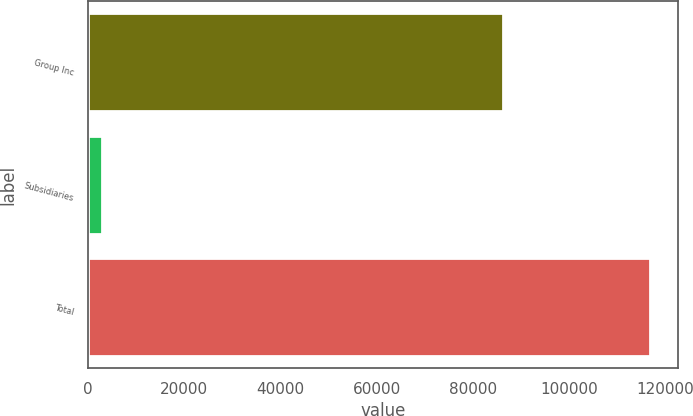Convert chart to OTSL. <chart><loc_0><loc_0><loc_500><loc_500><bar_chart><fcel>Group Inc<fcel>Subsidiaries<fcel>Total<nl><fcel>86255<fcel>3062<fcel>116850<nl></chart> 